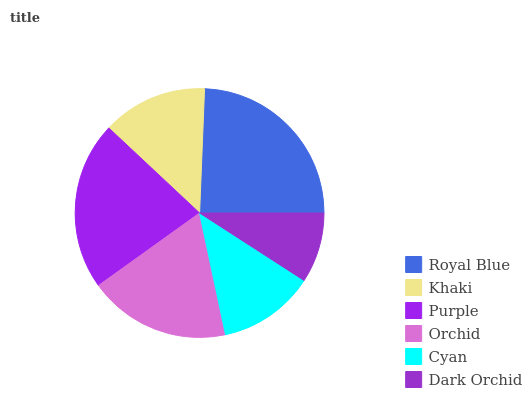Is Dark Orchid the minimum?
Answer yes or no. Yes. Is Royal Blue the maximum?
Answer yes or no. Yes. Is Khaki the minimum?
Answer yes or no. No. Is Khaki the maximum?
Answer yes or no. No. Is Royal Blue greater than Khaki?
Answer yes or no. Yes. Is Khaki less than Royal Blue?
Answer yes or no. Yes. Is Khaki greater than Royal Blue?
Answer yes or no. No. Is Royal Blue less than Khaki?
Answer yes or no. No. Is Orchid the high median?
Answer yes or no. Yes. Is Khaki the low median?
Answer yes or no. Yes. Is Purple the high median?
Answer yes or no. No. Is Dark Orchid the low median?
Answer yes or no. No. 